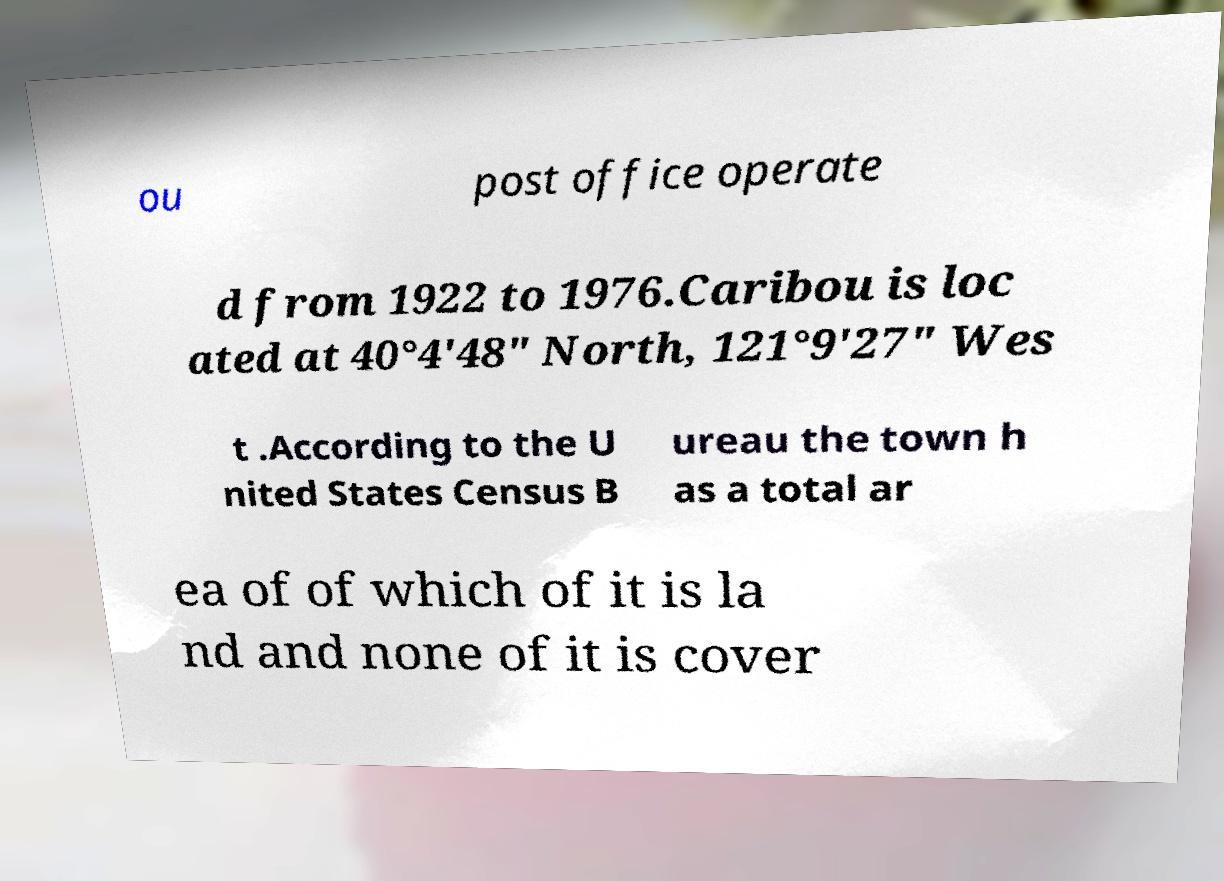Please identify and transcribe the text found in this image. ou post office operate d from 1922 to 1976.Caribou is loc ated at 40°4'48" North, 121°9'27" Wes t .According to the U nited States Census B ureau the town h as a total ar ea of of which of it is la nd and none of it is cover 